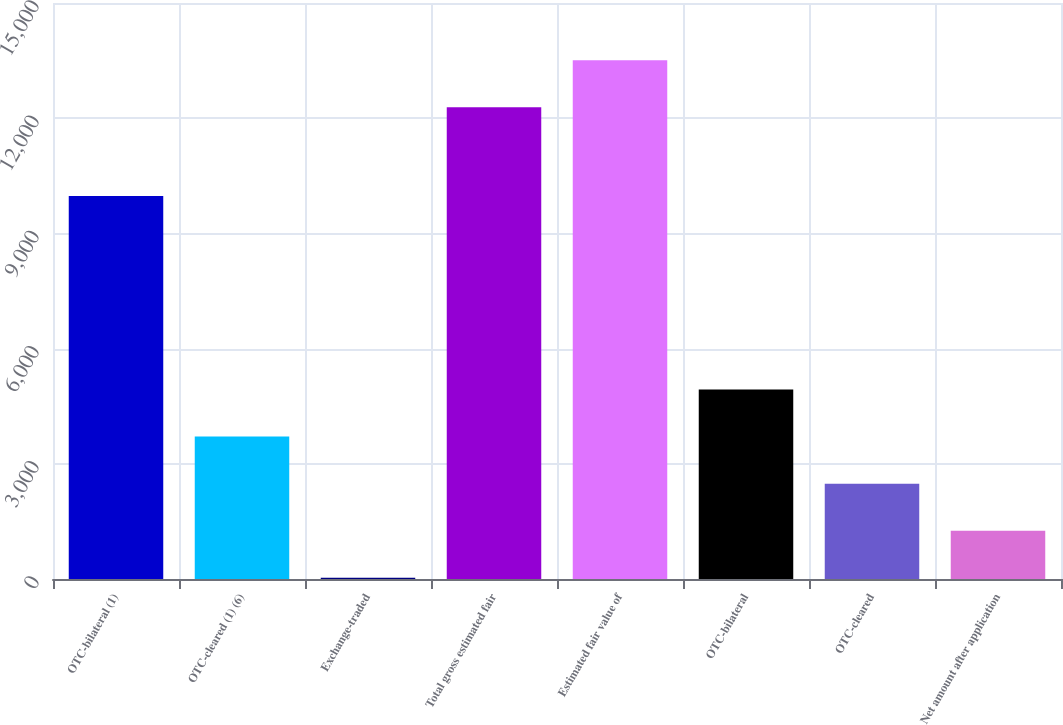Convert chart to OTSL. <chart><loc_0><loc_0><loc_500><loc_500><bar_chart><fcel>OTC-bilateral (1)<fcel>OTC-cleared (1) (6)<fcel>Exchange-traded<fcel>Total gross estimated fair<fcel>Estimated fair value of<fcel>OTC-bilateral<fcel>OTC-cleared<fcel>Net amount after application<nl><fcel>9976<fcel>3708.3<fcel>33<fcel>12284<fcel>13509.1<fcel>4933.4<fcel>2483.2<fcel>1258.1<nl></chart> 